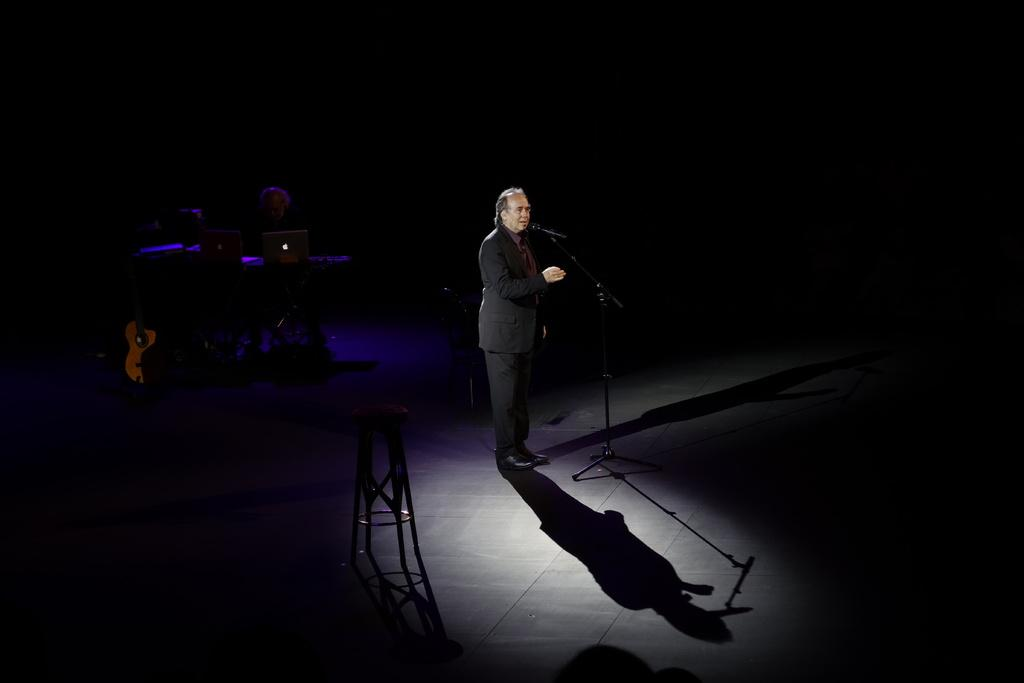What is the main subject of the image? The main subject of the image is a man standing in the middle. What is the man wearing? The man is wearing a black suit. What object is in front of the man? There is a mic in front of the man. What is located beside the man? There is a table beside the man. How many women are present in the image? There are no women present in the image; it features a man standing in the middle. What type of flowers can be seen on the table in the image? There are no flowers present on the table in the image; it only features a man, a mic, and a table. 